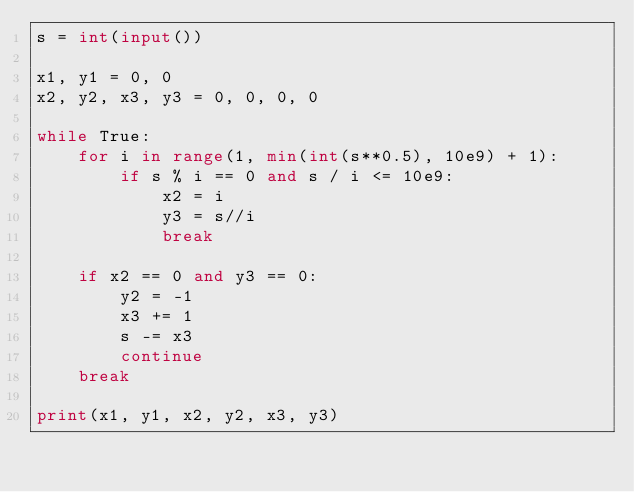Convert code to text. <code><loc_0><loc_0><loc_500><loc_500><_Python_>s = int(input())

x1, y1 = 0, 0
x2, y2, x3, y3 = 0, 0, 0, 0

while True:
    for i in range(1, min(int(s**0.5), 10e9) + 1):
        if s % i == 0 and s / i <= 10e9:
            x2 = i
            y3 = s//i
            break

    if x2 == 0 and y3 == 0:
        y2 = -1
        x3 += 1
        s -= x3
        continue
    break

print(x1, y1, x2, y2, x3, y3)</code> 